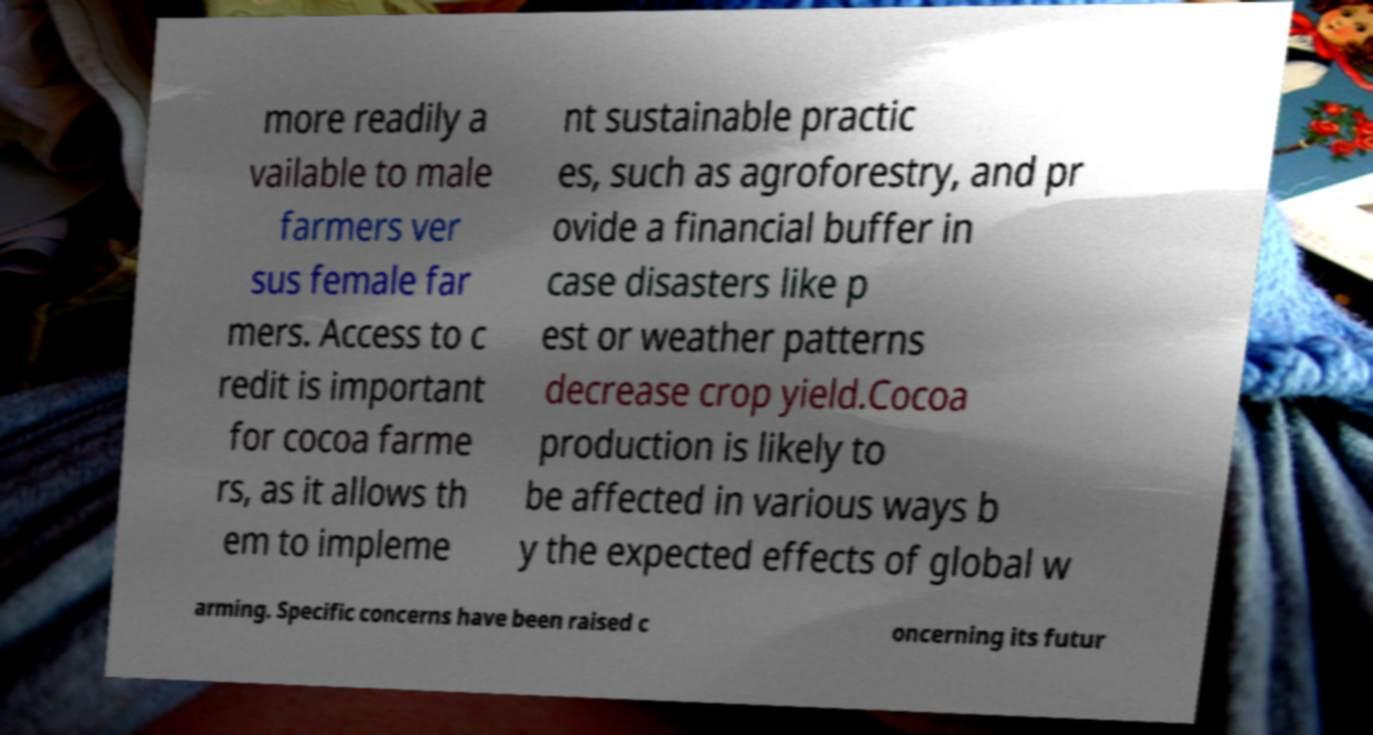For documentation purposes, I need the text within this image transcribed. Could you provide that? more readily a vailable to male farmers ver sus female far mers. Access to c redit is important for cocoa farme rs, as it allows th em to impleme nt sustainable practic es, such as agroforestry, and pr ovide a financial buffer in case disasters like p est or weather patterns decrease crop yield.Cocoa production is likely to be affected in various ways b y the expected effects of global w arming. Specific concerns have been raised c oncerning its futur 